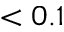Convert formula to latex. <formula><loc_0><loc_0><loc_500><loc_500>< 0 . 1</formula> 